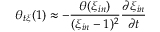<formula> <loc_0><loc_0><loc_500><loc_500>\theta _ { t \xi } ( 1 ) \approx - \frac { \theta ( \xi _ { i n } ) } { ( \xi _ { i n } - 1 ) ^ { 2 } } \frac { \partial \xi _ { i n } } { \partial t }</formula> 